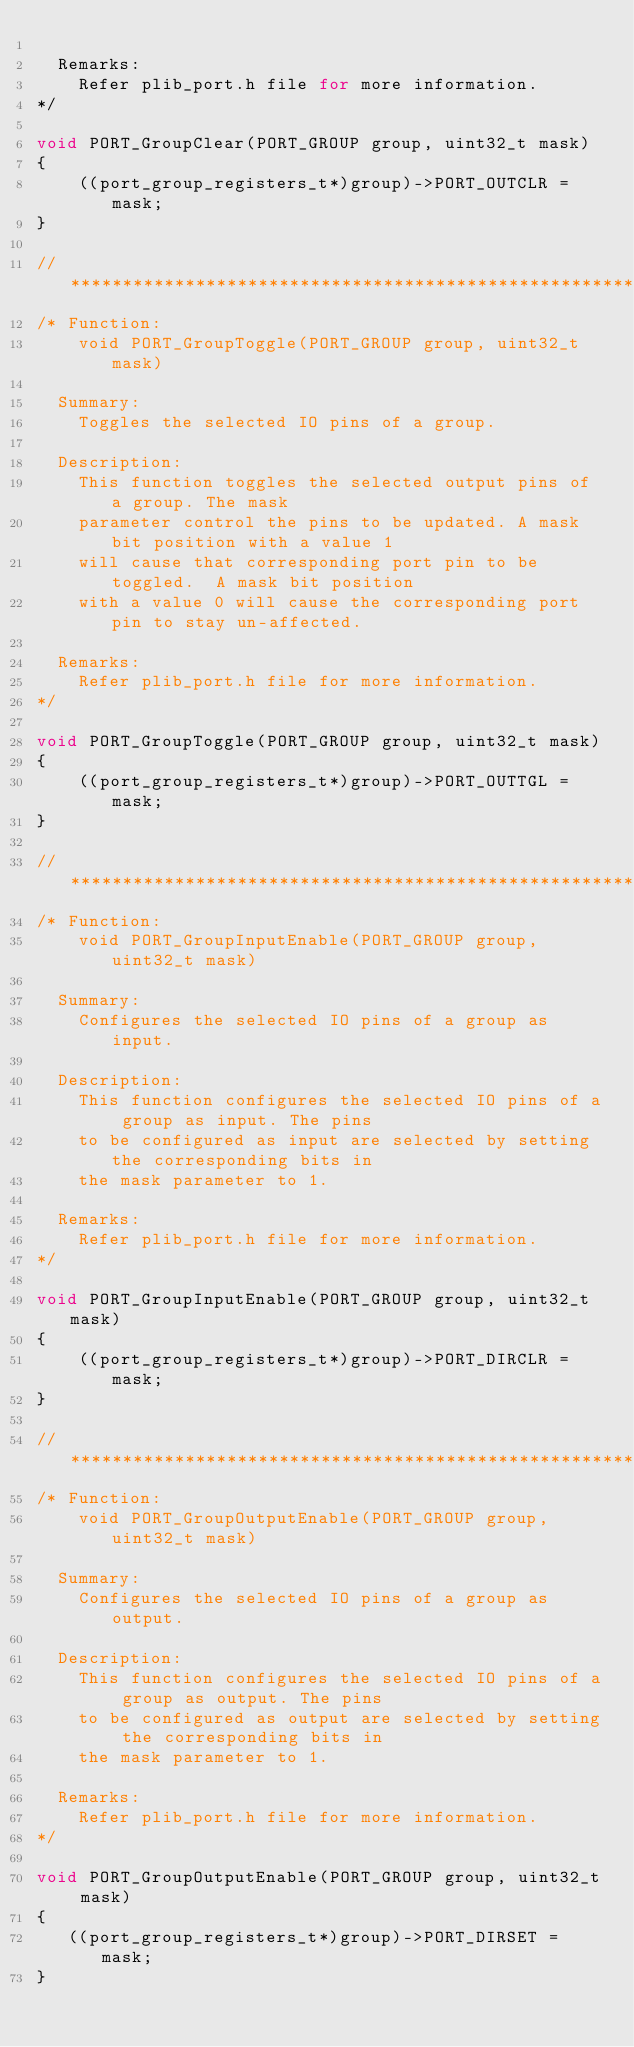Convert code to text. <code><loc_0><loc_0><loc_500><loc_500><_C_>
  Remarks:
    Refer plib_port.h file for more information.
*/

void PORT_GroupClear(PORT_GROUP group, uint32_t mask)
{
    ((port_group_registers_t*)group)->PORT_OUTCLR = mask;
}

// *****************************************************************************
/* Function:
    void PORT_GroupToggle(PORT_GROUP group, uint32_t mask)

  Summary:
    Toggles the selected IO pins of a group.

  Description:
    This function toggles the selected output pins of a group. The mask
    parameter control the pins to be updated. A mask bit position with a value 1
    will cause that corresponding port pin to be toggled.  A mask bit position
    with a value 0 will cause the corresponding port pin to stay un-affected.

  Remarks:
    Refer plib_port.h file for more information.
*/

void PORT_GroupToggle(PORT_GROUP group, uint32_t mask)
{
    ((port_group_registers_t*)group)->PORT_OUTTGL = mask;
}

// *****************************************************************************
/* Function:
    void PORT_GroupInputEnable(PORT_GROUP group, uint32_t mask)

  Summary:
    Configures the selected IO pins of a group as input.

  Description:
    This function configures the selected IO pins of a group as input. The pins
    to be configured as input are selected by setting the corresponding bits in
    the mask parameter to 1.

  Remarks:
    Refer plib_port.h file for more information.
*/

void PORT_GroupInputEnable(PORT_GROUP group, uint32_t mask)
{
    ((port_group_registers_t*)group)->PORT_DIRCLR = mask;
}

// *****************************************************************************
/* Function:
    void PORT_GroupOutputEnable(PORT_GROUP group, uint32_t mask)

  Summary:
    Configures the selected IO pins of a group as output.

  Description:
    This function configures the selected IO pins of a group as output. The pins
    to be configured as output are selected by setting the corresponding bits in
    the mask parameter to 1.

  Remarks:
    Refer plib_port.h file for more information.
*/

void PORT_GroupOutputEnable(PORT_GROUP group, uint32_t mask)
{
   ((port_group_registers_t*)group)->PORT_DIRSET = mask;
}
</code> 